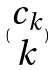<formula> <loc_0><loc_0><loc_500><loc_500>( \begin{matrix} c _ { k } \\ k \end{matrix} )</formula> 